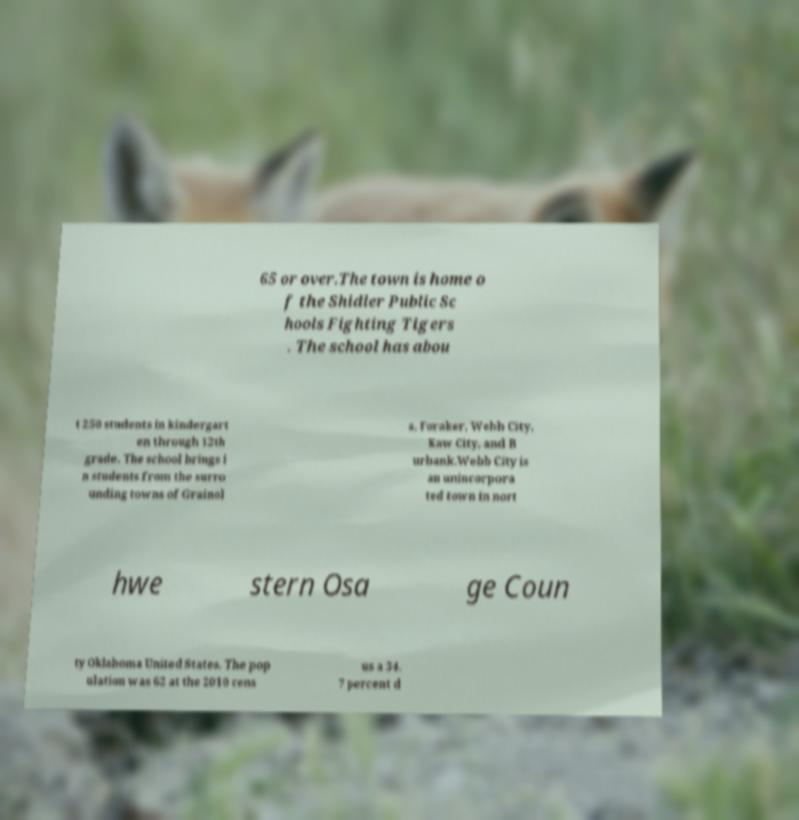Can you accurately transcribe the text from the provided image for me? 65 or over.The town is home o f the Shidler Public Sc hools Fighting Tigers . The school has abou t 250 students in kindergart en through 12th grade. The school brings i n students from the surro unding towns of Grainol a, Foraker, Webb City, Kaw City, and B urbank.Webb City is an unincorpora ted town in nort hwe stern Osa ge Coun ty Oklahoma United States. The pop ulation was 62 at the 2010 cens us a 34. 7 percent d 